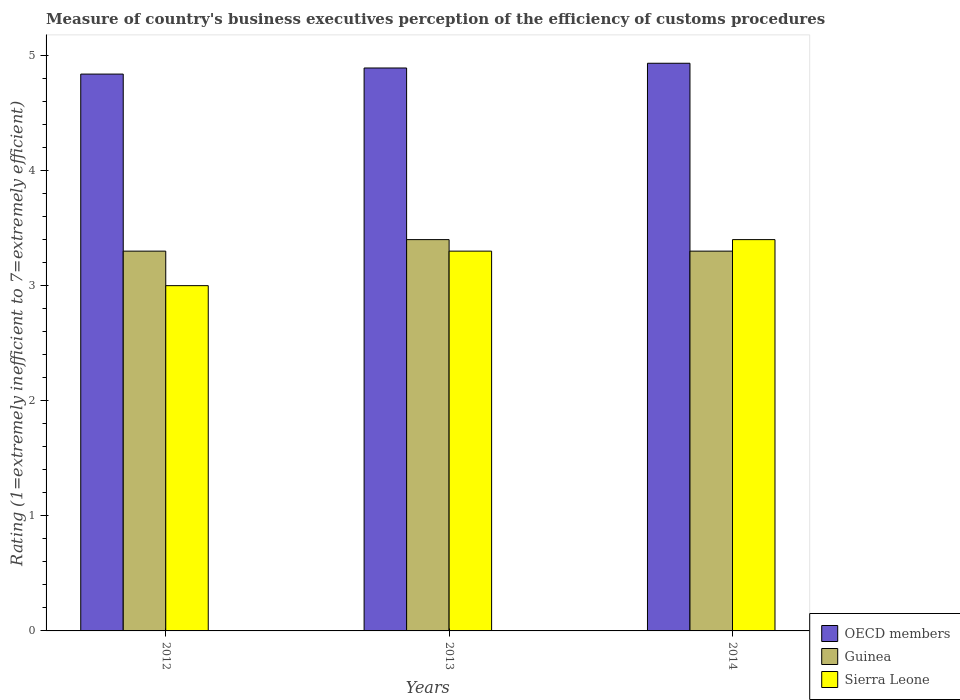Are the number of bars on each tick of the X-axis equal?
Offer a terse response. Yes. How many bars are there on the 2nd tick from the right?
Offer a terse response. 3. What is the label of the 2nd group of bars from the left?
Make the answer very short. 2013. What is the rating of the efficiency of customs procedure in Guinea in 2013?
Provide a succinct answer. 3.4. Across all years, what is the maximum rating of the efficiency of customs procedure in OECD members?
Offer a terse response. 4.93. In which year was the rating of the efficiency of customs procedure in OECD members maximum?
Give a very brief answer. 2014. What is the total rating of the efficiency of customs procedure in OECD members in the graph?
Your answer should be compact. 14.66. What is the difference between the rating of the efficiency of customs procedure in Sierra Leone in 2012 and that in 2013?
Your answer should be compact. -0.3. What is the difference between the rating of the efficiency of customs procedure in Sierra Leone in 2012 and the rating of the efficiency of customs procedure in Guinea in 2013?
Provide a succinct answer. -0.4. What is the average rating of the efficiency of customs procedure in Sierra Leone per year?
Make the answer very short. 3.23. In the year 2013, what is the difference between the rating of the efficiency of customs procedure in OECD members and rating of the efficiency of customs procedure in Guinea?
Give a very brief answer. 1.49. In how many years, is the rating of the efficiency of customs procedure in OECD members greater than 2.8?
Your answer should be very brief. 3. What is the ratio of the rating of the efficiency of customs procedure in Sierra Leone in 2012 to that in 2014?
Provide a short and direct response. 0.88. Is the difference between the rating of the efficiency of customs procedure in OECD members in 2012 and 2013 greater than the difference between the rating of the efficiency of customs procedure in Guinea in 2012 and 2013?
Your answer should be compact. Yes. What is the difference between the highest and the second highest rating of the efficiency of customs procedure in Sierra Leone?
Ensure brevity in your answer.  0.1. What is the difference between the highest and the lowest rating of the efficiency of customs procedure in Guinea?
Offer a terse response. 0.1. What does the 3rd bar from the right in 2014 represents?
Ensure brevity in your answer.  OECD members. Is it the case that in every year, the sum of the rating of the efficiency of customs procedure in Guinea and rating of the efficiency of customs procedure in OECD members is greater than the rating of the efficiency of customs procedure in Sierra Leone?
Your response must be concise. Yes. How many bars are there?
Your answer should be very brief. 9. Are all the bars in the graph horizontal?
Provide a short and direct response. No. Are the values on the major ticks of Y-axis written in scientific E-notation?
Offer a very short reply. No. Does the graph contain grids?
Your answer should be very brief. No. Where does the legend appear in the graph?
Your answer should be very brief. Bottom right. What is the title of the graph?
Your answer should be very brief. Measure of country's business executives perception of the efficiency of customs procedures. Does "Sub-Saharan Africa (all income levels)" appear as one of the legend labels in the graph?
Offer a very short reply. No. What is the label or title of the X-axis?
Give a very brief answer. Years. What is the label or title of the Y-axis?
Make the answer very short. Rating (1=extremely inefficient to 7=extremely efficient). What is the Rating (1=extremely inefficient to 7=extremely efficient) of OECD members in 2012?
Your response must be concise. 4.84. What is the Rating (1=extremely inefficient to 7=extremely efficient) of OECD members in 2013?
Your answer should be compact. 4.89. What is the Rating (1=extremely inefficient to 7=extremely efficient) of OECD members in 2014?
Make the answer very short. 4.93. What is the Rating (1=extremely inefficient to 7=extremely efficient) in Guinea in 2014?
Make the answer very short. 3.3. What is the Rating (1=extremely inefficient to 7=extremely efficient) of Sierra Leone in 2014?
Ensure brevity in your answer.  3.4. Across all years, what is the maximum Rating (1=extremely inefficient to 7=extremely efficient) in OECD members?
Give a very brief answer. 4.93. Across all years, what is the maximum Rating (1=extremely inefficient to 7=extremely efficient) in Guinea?
Provide a short and direct response. 3.4. Across all years, what is the maximum Rating (1=extremely inefficient to 7=extremely efficient) of Sierra Leone?
Give a very brief answer. 3.4. Across all years, what is the minimum Rating (1=extremely inefficient to 7=extremely efficient) in OECD members?
Keep it short and to the point. 4.84. What is the total Rating (1=extremely inefficient to 7=extremely efficient) in OECD members in the graph?
Offer a very short reply. 14.66. What is the difference between the Rating (1=extremely inefficient to 7=extremely efficient) of OECD members in 2012 and that in 2013?
Make the answer very short. -0.05. What is the difference between the Rating (1=extremely inefficient to 7=extremely efficient) of Guinea in 2012 and that in 2013?
Offer a very short reply. -0.1. What is the difference between the Rating (1=extremely inefficient to 7=extremely efficient) in OECD members in 2012 and that in 2014?
Keep it short and to the point. -0.09. What is the difference between the Rating (1=extremely inefficient to 7=extremely efficient) in Guinea in 2012 and that in 2014?
Your response must be concise. 0. What is the difference between the Rating (1=extremely inefficient to 7=extremely efficient) in OECD members in 2013 and that in 2014?
Ensure brevity in your answer.  -0.04. What is the difference between the Rating (1=extremely inefficient to 7=extremely efficient) in Guinea in 2013 and that in 2014?
Keep it short and to the point. 0.1. What is the difference between the Rating (1=extremely inefficient to 7=extremely efficient) in OECD members in 2012 and the Rating (1=extremely inefficient to 7=extremely efficient) in Guinea in 2013?
Your response must be concise. 1.44. What is the difference between the Rating (1=extremely inefficient to 7=extremely efficient) in OECD members in 2012 and the Rating (1=extremely inefficient to 7=extremely efficient) in Sierra Leone in 2013?
Provide a succinct answer. 1.54. What is the difference between the Rating (1=extremely inefficient to 7=extremely efficient) of OECD members in 2012 and the Rating (1=extremely inefficient to 7=extremely efficient) of Guinea in 2014?
Offer a terse response. 1.54. What is the difference between the Rating (1=extremely inefficient to 7=extremely efficient) in OECD members in 2012 and the Rating (1=extremely inefficient to 7=extremely efficient) in Sierra Leone in 2014?
Keep it short and to the point. 1.44. What is the difference between the Rating (1=extremely inefficient to 7=extremely efficient) in OECD members in 2013 and the Rating (1=extremely inefficient to 7=extremely efficient) in Guinea in 2014?
Offer a terse response. 1.59. What is the difference between the Rating (1=extremely inefficient to 7=extremely efficient) in OECD members in 2013 and the Rating (1=extremely inefficient to 7=extremely efficient) in Sierra Leone in 2014?
Ensure brevity in your answer.  1.49. What is the difference between the Rating (1=extremely inefficient to 7=extremely efficient) of Guinea in 2013 and the Rating (1=extremely inefficient to 7=extremely efficient) of Sierra Leone in 2014?
Offer a terse response. 0. What is the average Rating (1=extremely inefficient to 7=extremely efficient) in OECD members per year?
Offer a terse response. 4.89. What is the average Rating (1=extremely inefficient to 7=extremely efficient) in Sierra Leone per year?
Your answer should be compact. 3.23. In the year 2012, what is the difference between the Rating (1=extremely inefficient to 7=extremely efficient) of OECD members and Rating (1=extremely inefficient to 7=extremely efficient) of Guinea?
Give a very brief answer. 1.54. In the year 2012, what is the difference between the Rating (1=extremely inefficient to 7=extremely efficient) of OECD members and Rating (1=extremely inefficient to 7=extremely efficient) of Sierra Leone?
Give a very brief answer. 1.84. In the year 2013, what is the difference between the Rating (1=extremely inefficient to 7=extremely efficient) of OECD members and Rating (1=extremely inefficient to 7=extremely efficient) of Guinea?
Provide a short and direct response. 1.49. In the year 2013, what is the difference between the Rating (1=extremely inefficient to 7=extremely efficient) of OECD members and Rating (1=extremely inefficient to 7=extremely efficient) of Sierra Leone?
Keep it short and to the point. 1.59. In the year 2014, what is the difference between the Rating (1=extremely inefficient to 7=extremely efficient) in OECD members and Rating (1=extremely inefficient to 7=extremely efficient) in Guinea?
Ensure brevity in your answer.  1.63. In the year 2014, what is the difference between the Rating (1=extremely inefficient to 7=extremely efficient) in OECD members and Rating (1=extremely inefficient to 7=extremely efficient) in Sierra Leone?
Keep it short and to the point. 1.53. In the year 2014, what is the difference between the Rating (1=extremely inefficient to 7=extremely efficient) in Guinea and Rating (1=extremely inefficient to 7=extremely efficient) in Sierra Leone?
Offer a very short reply. -0.1. What is the ratio of the Rating (1=extremely inefficient to 7=extremely efficient) of Guinea in 2012 to that in 2013?
Offer a very short reply. 0.97. What is the ratio of the Rating (1=extremely inefficient to 7=extremely efficient) in OECD members in 2012 to that in 2014?
Your response must be concise. 0.98. What is the ratio of the Rating (1=extremely inefficient to 7=extremely efficient) in Sierra Leone in 2012 to that in 2014?
Make the answer very short. 0.88. What is the ratio of the Rating (1=extremely inefficient to 7=extremely efficient) of Guinea in 2013 to that in 2014?
Your response must be concise. 1.03. What is the ratio of the Rating (1=extremely inefficient to 7=extremely efficient) in Sierra Leone in 2013 to that in 2014?
Provide a succinct answer. 0.97. What is the difference between the highest and the second highest Rating (1=extremely inefficient to 7=extremely efficient) of OECD members?
Ensure brevity in your answer.  0.04. What is the difference between the highest and the second highest Rating (1=extremely inefficient to 7=extremely efficient) of Guinea?
Your response must be concise. 0.1. What is the difference between the highest and the lowest Rating (1=extremely inefficient to 7=extremely efficient) in OECD members?
Give a very brief answer. 0.09. What is the difference between the highest and the lowest Rating (1=extremely inefficient to 7=extremely efficient) of Sierra Leone?
Make the answer very short. 0.4. 